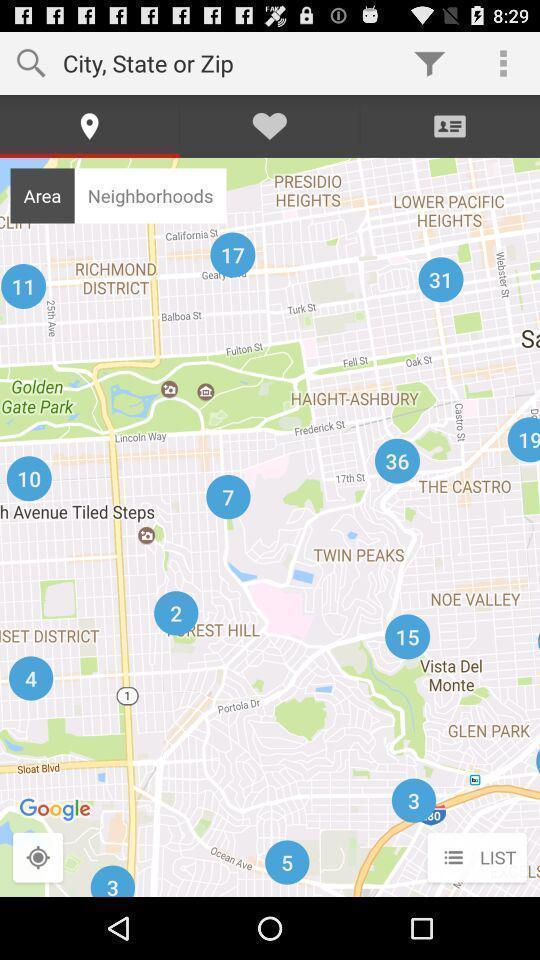Describe this image in words. Search page to find location. 